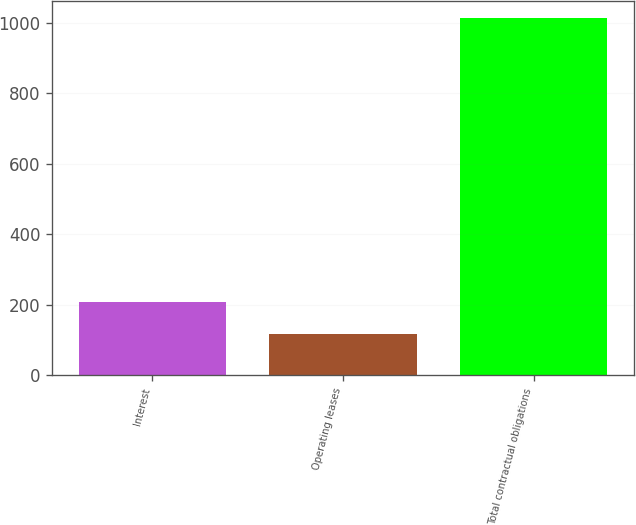Convert chart. <chart><loc_0><loc_0><loc_500><loc_500><bar_chart><fcel>Interest<fcel>Operating leases<fcel>Total contractual obligations<nl><fcel>206.6<fcel>117<fcel>1013<nl></chart> 